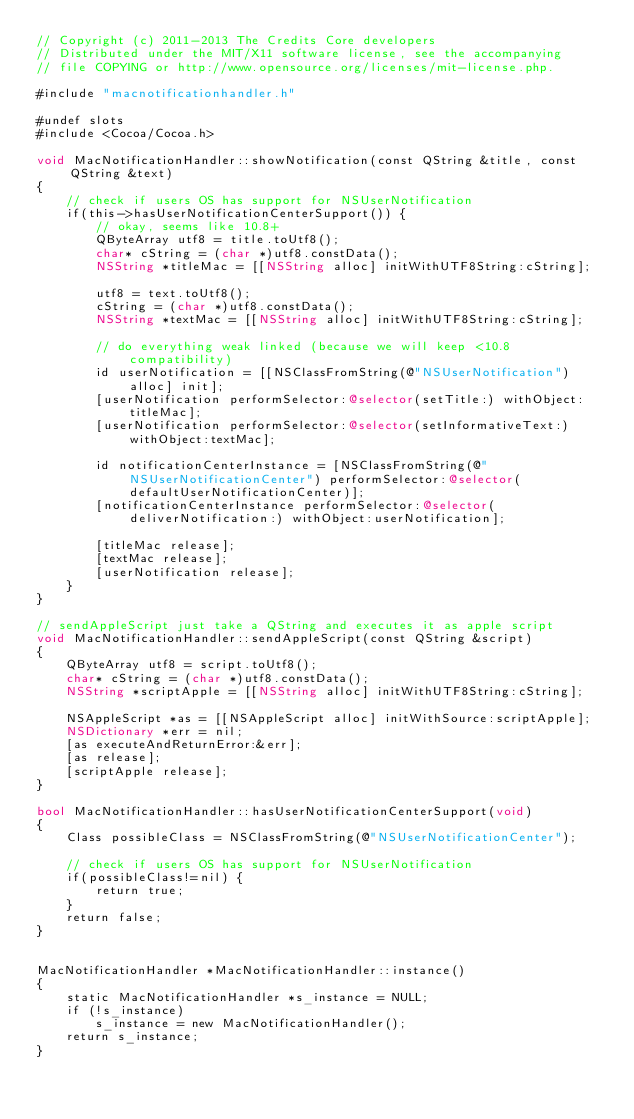Convert code to text. <code><loc_0><loc_0><loc_500><loc_500><_ObjectiveC_>// Copyright (c) 2011-2013 The Credits Core developers
// Distributed under the MIT/X11 software license, see the accompanying
// file COPYING or http://www.opensource.org/licenses/mit-license.php.

#include "macnotificationhandler.h"

#undef slots
#include <Cocoa/Cocoa.h>

void MacNotificationHandler::showNotification(const QString &title, const QString &text)
{
    // check if users OS has support for NSUserNotification
    if(this->hasUserNotificationCenterSupport()) {
        // okay, seems like 10.8+
        QByteArray utf8 = title.toUtf8();
        char* cString = (char *)utf8.constData();
        NSString *titleMac = [[NSString alloc] initWithUTF8String:cString];

        utf8 = text.toUtf8();
        cString = (char *)utf8.constData();
        NSString *textMac = [[NSString alloc] initWithUTF8String:cString];

        // do everything weak linked (because we will keep <10.8 compatibility)
        id userNotification = [[NSClassFromString(@"NSUserNotification") alloc] init];
        [userNotification performSelector:@selector(setTitle:) withObject:titleMac];
        [userNotification performSelector:@selector(setInformativeText:) withObject:textMac];

        id notificationCenterInstance = [NSClassFromString(@"NSUserNotificationCenter") performSelector:@selector(defaultUserNotificationCenter)];
        [notificationCenterInstance performSelector:@selector(deliverNotification:) withObject:userNotification];

        [titleMac release];
        [textMac release];
        [userNotification release];
    }
}

// sendAppleScript just take a QString and executes it as apple script
void MacNotificationHandler::sendAppleScript(const QString &script)
{
    QByteArray utf8 = script.toUtf8();
    char* cString = (char *)utf8.constData();
    NSString *scriptApple = [[NSString alloc] initWithUTF8String:cString];

    NSAppleScript *as = [[NSAppleScript alloc] initWithSource:scriptApple];
    NSDictionary *err = nil;
    [as executeAndReturnError:&err];
    [as release];
    [scriptApple release];
}

bool MacNotificationHandler::hasUserNotificationCenterSupport(void)
{
    Class possibleClass = NSClassFromString(@"NSUserNotificationCenter");

    // check if users OS has support for NSUserNotification
    if(possibleClass!=nil) {
        return true;
    }
    return false;
}


MacNotificationHandler *MacNotificationHandler::instance()
{
    static MacNotificationHandler *s_instance = NULL;
    if (!s_instance)
        s_instance = new MacNotificationHandler();
    return s_instance;
}
</code> 